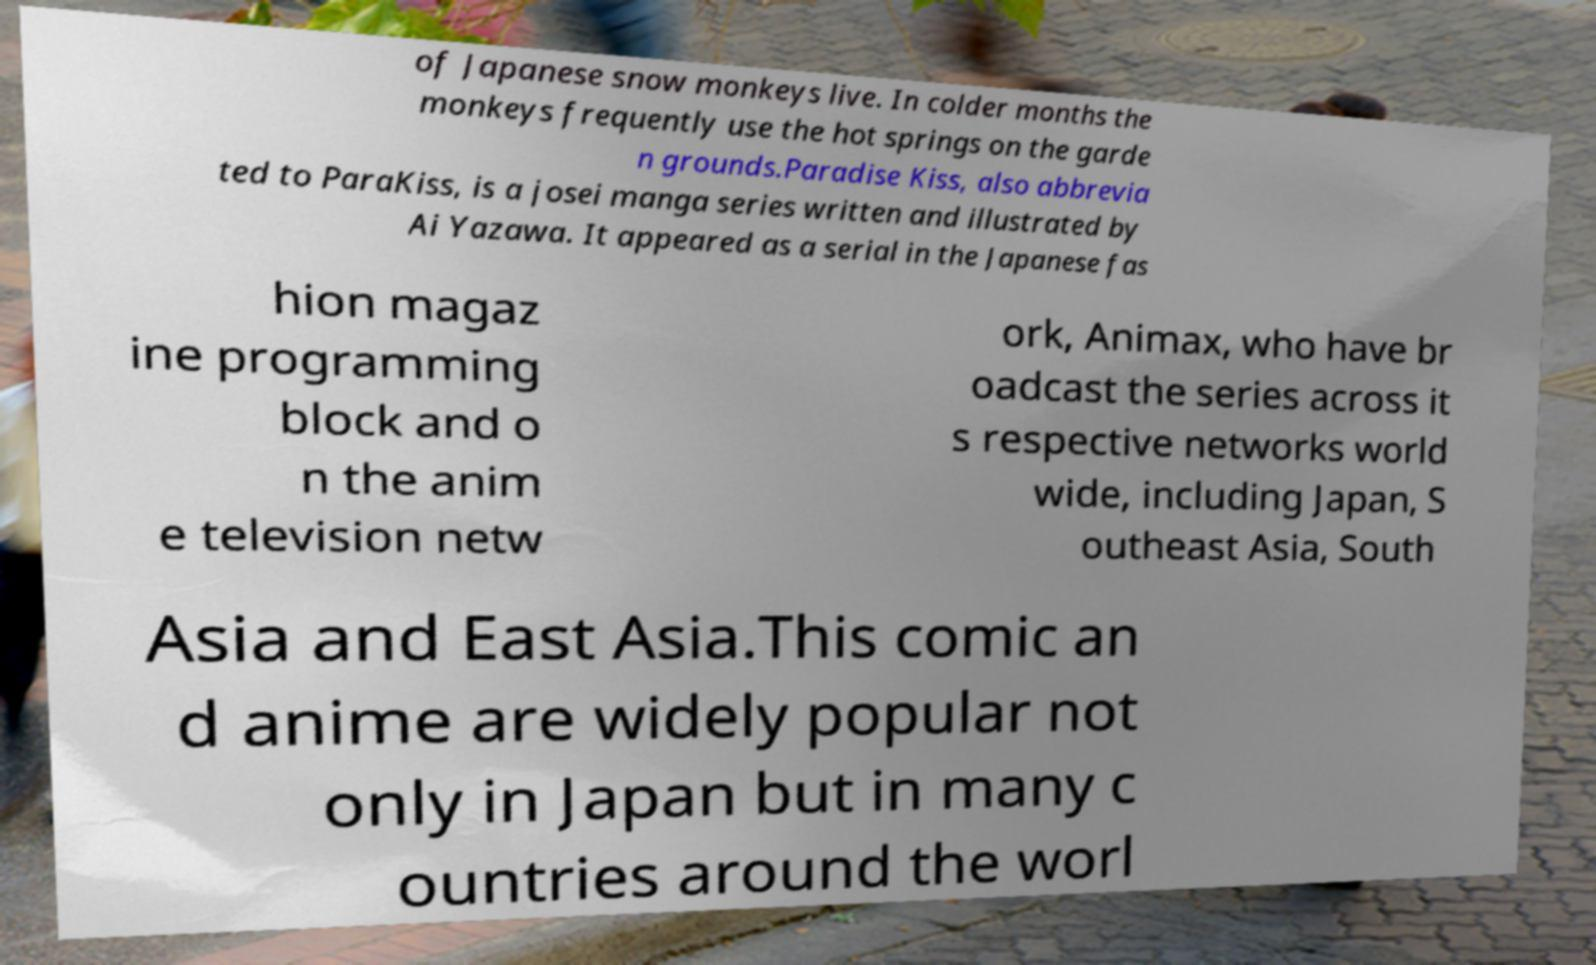What messages or text are displayed in this image? I need them in a readable, typed format. of Japanese snow monkeys live. In colder months the monkeys frequently use the hot springs on the garde n grounds.Paradise Kiss, also abbrevia ted to ParaKiss, is a josei manga series written and illustrated by Ai Yazawa. It appeared as a serial in the Japanese fas hion magaz ine programming block and o n the anim e television netw ork, Animax, who have br oadcast the series across it s respective networks world wide, including Japan, S outheast Asia, South Asia and East Asia.This comic an d anime are widely popular not only in Japan but in many c ountries around the worl 